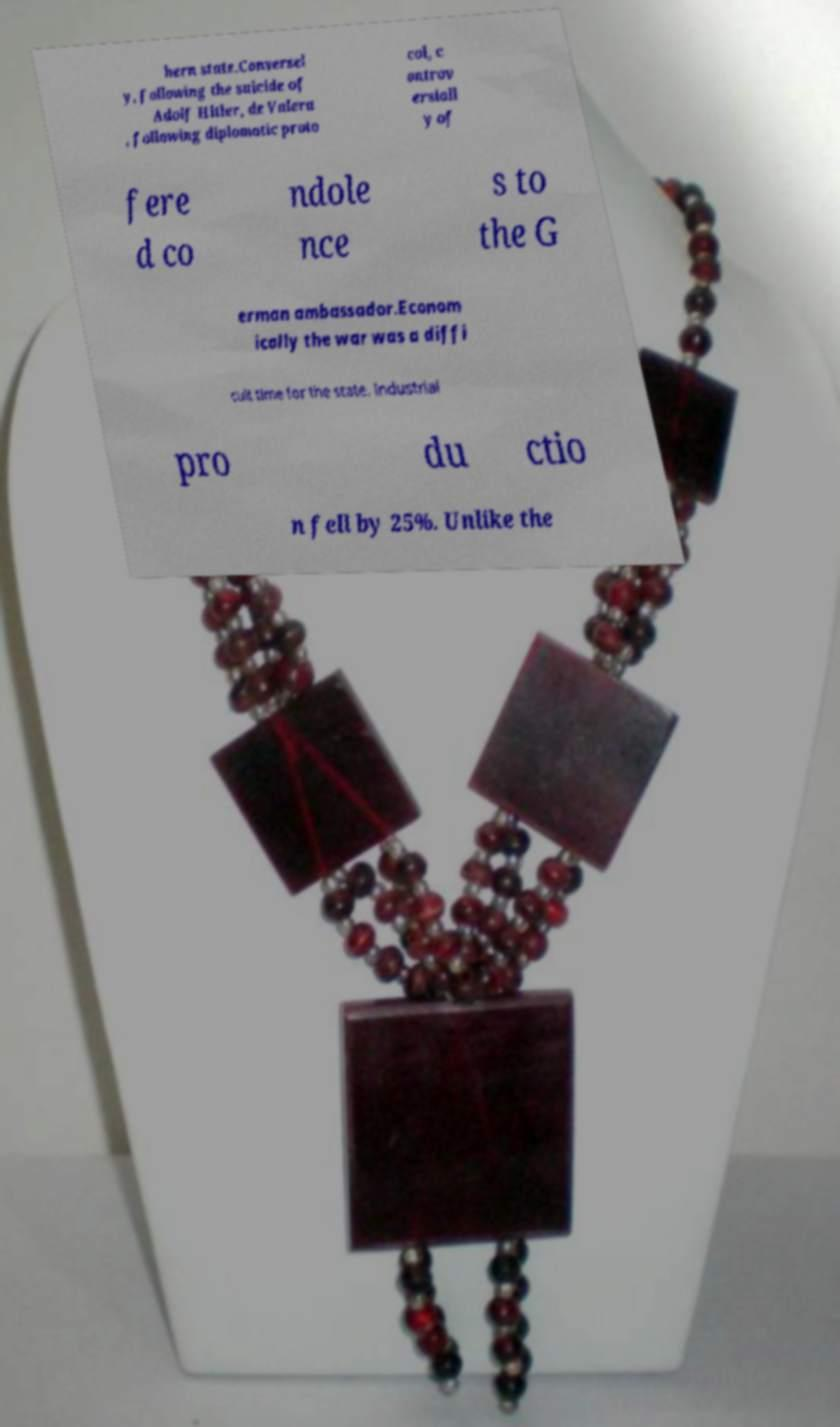Can you accurately transcribe the text from the provided image for me? hern state.Conversel y, following the suicide of Adolf Hitler, de Valera , following diplomatic proto col, c ontrov ersiall y of fere d co ndole nce s to the G erman ambassador.Econom ically the war was a diffi cult time for the state. Industrial pro du ctio n fell by 25%. Unlike the 